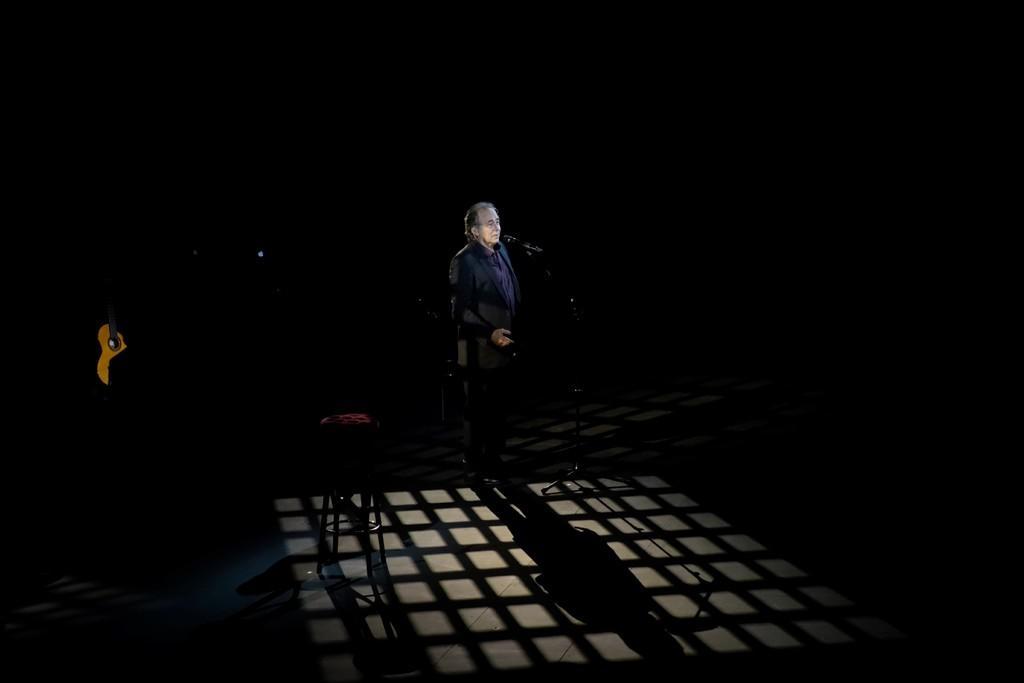How would you summarize this image in a sentence or two? In this image we can see a man. In front of the man we can see a mic with stand. Beside the man we can see a chair. On the left side, we can see a guitar. The background of the image is dark. 